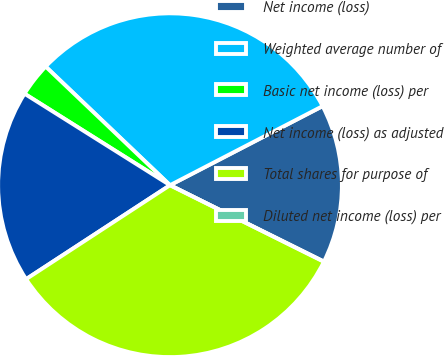Convert chart to OTSL. <chart><loc_0><loc_0><loc_500><loc_500><pie_chart><fcel>Net income (loss)<fcel>Weighted average number of<fcel>Basic net income (loss) per<fcel>Net income (loss) as adjusted<fcel>Total shares for purpose of<fcel>Diluted net income (loss) per<nl><fcel>14.95%<fcel>30.27%<fcel>3.19%<fcel>18.14%<fcel>33.46%<fcel>0.0%<nl></chart> 